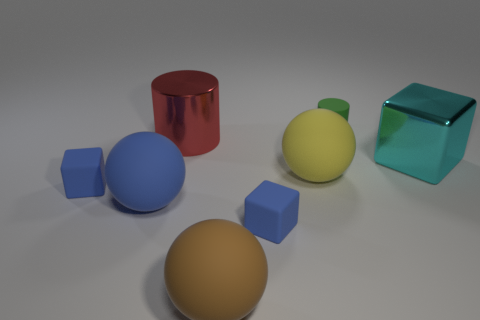The other thing that is the same material as the cyan object is what shape?
Ensure brevity in your answer.  Cylinder. What color is the shiny cube that is the same size as the yellow rubber object?
Make the answer very short. Cyan. There is a metal object on the left side of the shiny cube; is its size the same as the tiny green cylinder?
Provide a succinct answer. No. What number of small things are there?
Give a very brief answer. 3. What number of balls are blue objects or large things?
Offer a very short reply. 3. There is a matte thing that is to the right of the yellow matte sphere; how many large things are to the right of it?
Keep it short and to the point. 1. Is the material of the large blue object the same as the large cyan object?
Keep it short and to the point. No. Are there any objects made of the same material as the large cylinder?
Offer a very short reply. Yes. What color is the small object that is behind the small block that is behind the blue matte thing that is to the right of the big blue thing?
Make the answer very short. Green. What number of purple things are either small cylinders or large cylinders?
Keep it short and to the point. 0. 